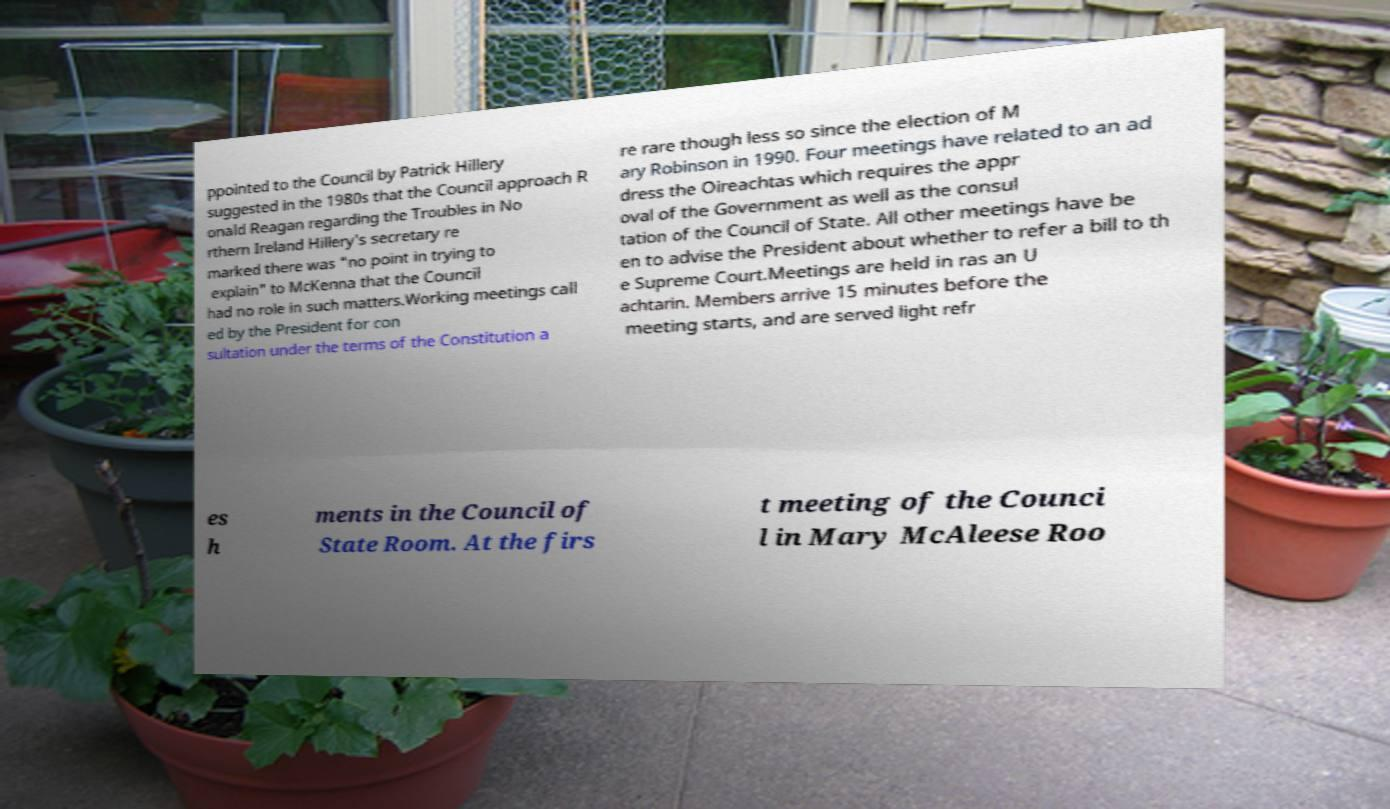Could you extract and type out the text from this image? ppointed to the Council by Patrick Hillery suggested in the 1980s that the Council approach R onald Reagan regarding the Troubles in No rthern Ireland Hillery's secretary re marked there was "no point in trying to explain" to McKenna that the Council had no role in such matters.Working meetings call ed by the President for con sultation under the terms of the Constitution a re rare though less so since the election of M ary Robinson in 1990. Four meetings have related to an ad dress the Oireachtas which requires the appr oval of the Government as well as the consul tation of the Council of State. All other meetings have be en to advise the President about whether to refer a bill to th e Supreme Court.Meetings are held in ras an U achtarin. Members arrive 15 minutes before the meeting starts, and are served light refr es h ments in the Council of State Room. At the firs t meeting of the Counci l in Mary McAleese Roo 